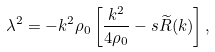Convert formula to latex. <formula><loc_0><loc_0><loc_500><loc_500>\lambda ^ { 2 } = - k ^ { 2 } \rho _ { 0 } \left [ \frac { k ^ { 2 } } { 4 \rho _ { 0 } } - s \widetilde { R } ( k ) \right ] ,</formula> 